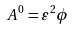<formula> <loc_0><loc_0><loc_500><loc_500>A ^ { 0 } = \varepsilon ^ { 2 } \phi</formula> 